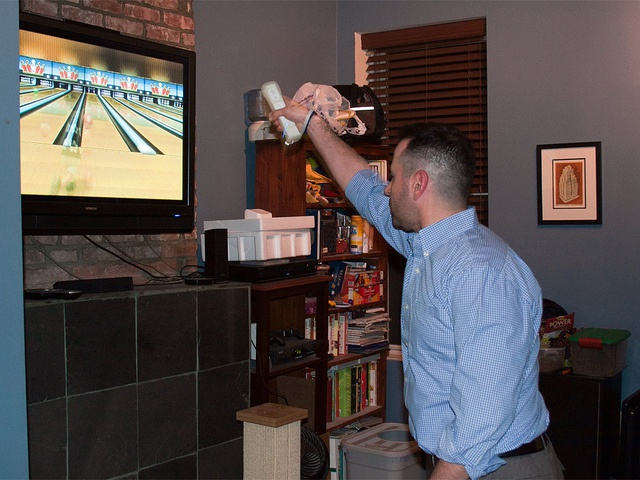Describe the objects in this image and their specific colors. I can see people in gray, darkgray, and black tones, tv in gray, khaki, black, and ivory tones, book in gray, black, maroon, and brown tones, remote in gray, black, and maroon tones, and book in gray, darkgreen, black, and olive tones in this image. 